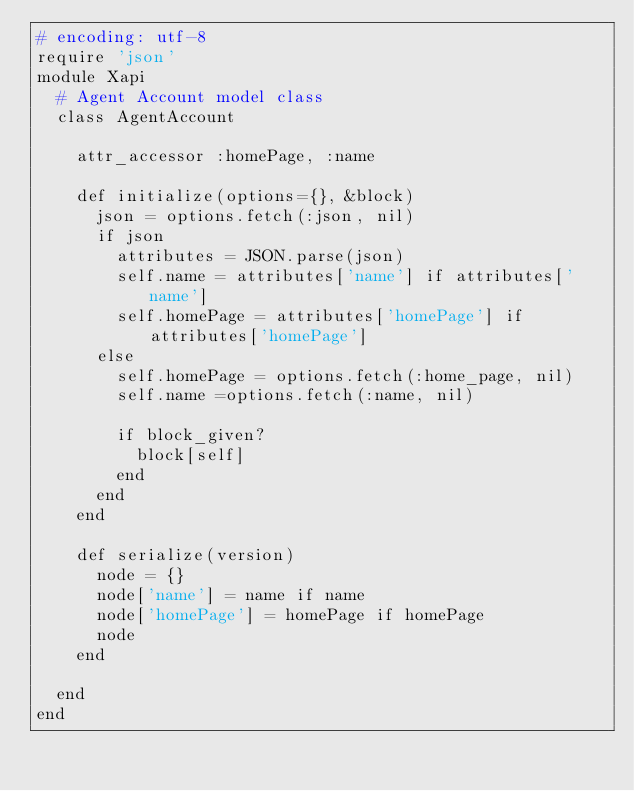Convert code to text. <code><loc_0><loc_0><loc_500><loc_500><_Ruby_># encoding: utf-8
require 'json'
module Xapi
  # Agent Account model class
  class AgentAccount

    attr_accessor :homePage, :name

    def initialize(options={}, &block)
      json = options.fetch(:json, nil)
      if json
        attributes = JSON.parse(json)
        self.name = attributes['name'] if attributes['name']
        self.homePage = attributes['homePage'] if attributes['homePage']
      else
        self.homePage = options.fetch(:home_page, nil)
        self.name =options.fetch(:name, nil)

        if block_given?
          block[self]
        end
      end
    end

    def serialize(version)
      node = {}
      node['name'] = name if name
      node['homePage'] = homePage if homePage
      node
    end

  end
end</code> 